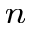<formula> <loc_0><loc_0><loc_500><loc_500>_ { n }</formula> 